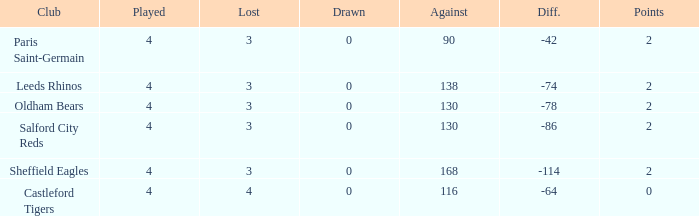What is the sum of losses for teams with less than 4 games played? None. 